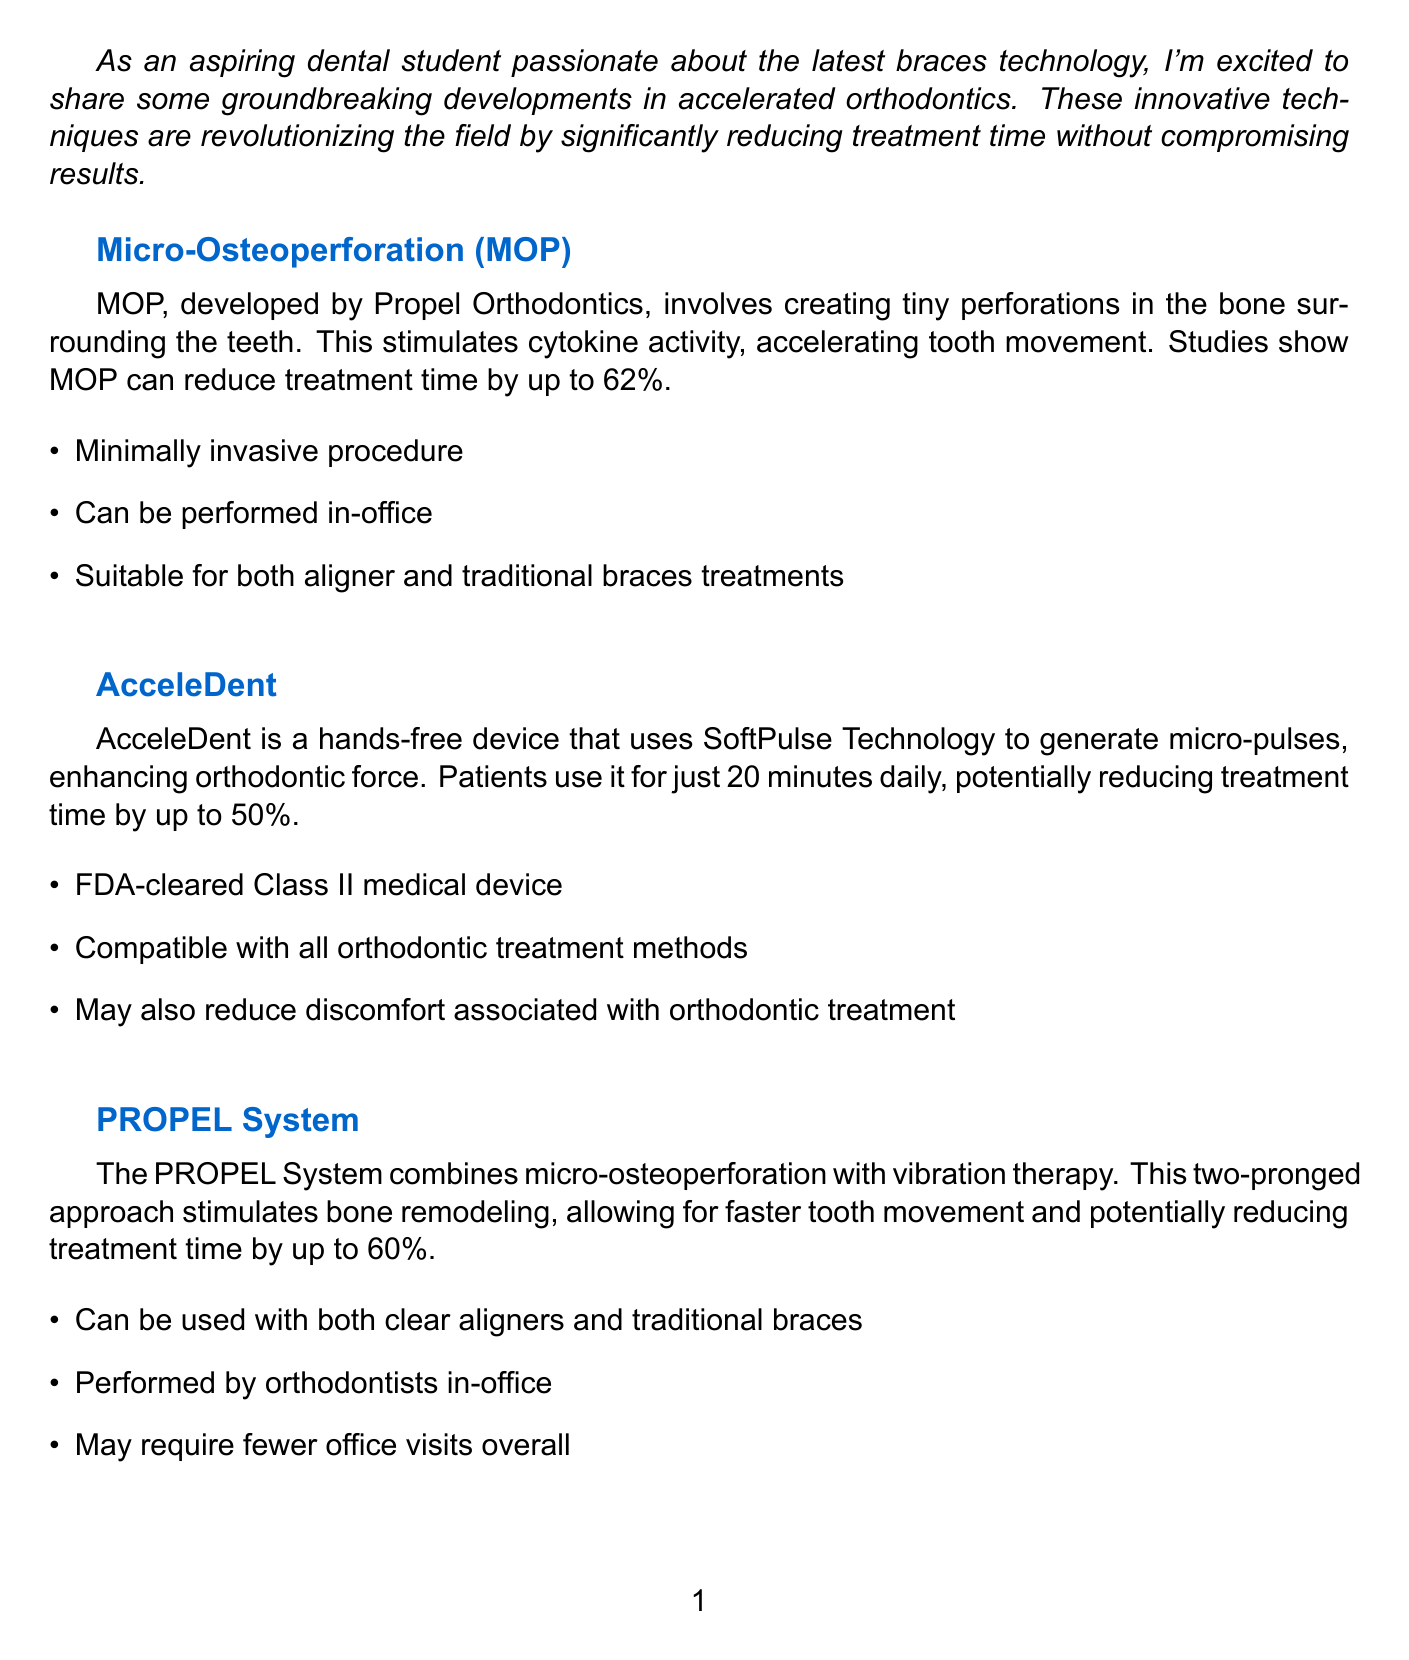What is the title of the newsletter? The title of the newsletter is the main heading presented at the top of the document.
Answer: Accelerating Your Smile: Cutting-Edge Orthodontic Techniques What does MOP stand for? MOP is an abbreviation mentioned in the document, specifically related to Micro-Osteoperforation.
Answer: Micro-Osteoperforation How much can MOP reduce treatment time by? The document states that studies show MOP can reduce treatment time significantly, indicating a specific percentage.
Answer: Up to 62% What is AcceleDent used for? AcceleDent is described in the document as a device used for enhancing orthodontic force during treatment.
Answer: Enhancing orthodontic force How many minutes daily do patients use AcceleDent? The time mentioned in the document refers to how long patients need to utilize the AcceleDent device each day.
Answer: 20 minutes What is the potential reduction in treatment time with Low-Level Laser Therapy? The document specifies a range for reduction in treatment time associated with Low-Level Laser Therapy.
Answer: 25-30% Which two techniques are combined in the PROPEL System? The PROPEL System involves two specific approaches mentioned in the document that work together for orthodontic treatment.
Answer: Micro-osteoperforation and vibration therapy What was the initial projected treatment duration for Sarah? The document provides a comparison of the original and actual treatment time for a specific case study.
Answer: 18 months What type of patient is Sarah? The document gives a brief profile of Sarah, highlighting her profession and preference for orthodontic treatment.
Answer: 28-year-old professional What organization is mentioned in the call to action? In the call to action, a specific association is referenced that relates to orthodontics and upcoming events.
Answer: American Association of Orthodontists (AAO) 